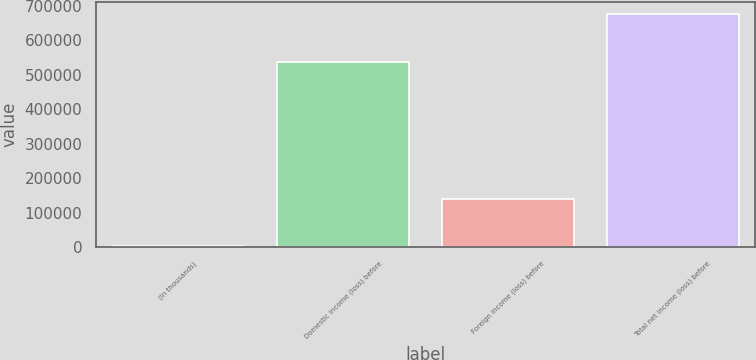Convert chart. <chart><loc_0><loc_0><loc_500><loc_500><bar_chart><fcel>(In thousands)<fcel>Domestic income (loss) before<fcel>Foreign income (loss) before<fcel>Total net income (loss) before<nl><fcel>2007<fcel>538257<fcel>138978<fcel>677235<nl></chart> 